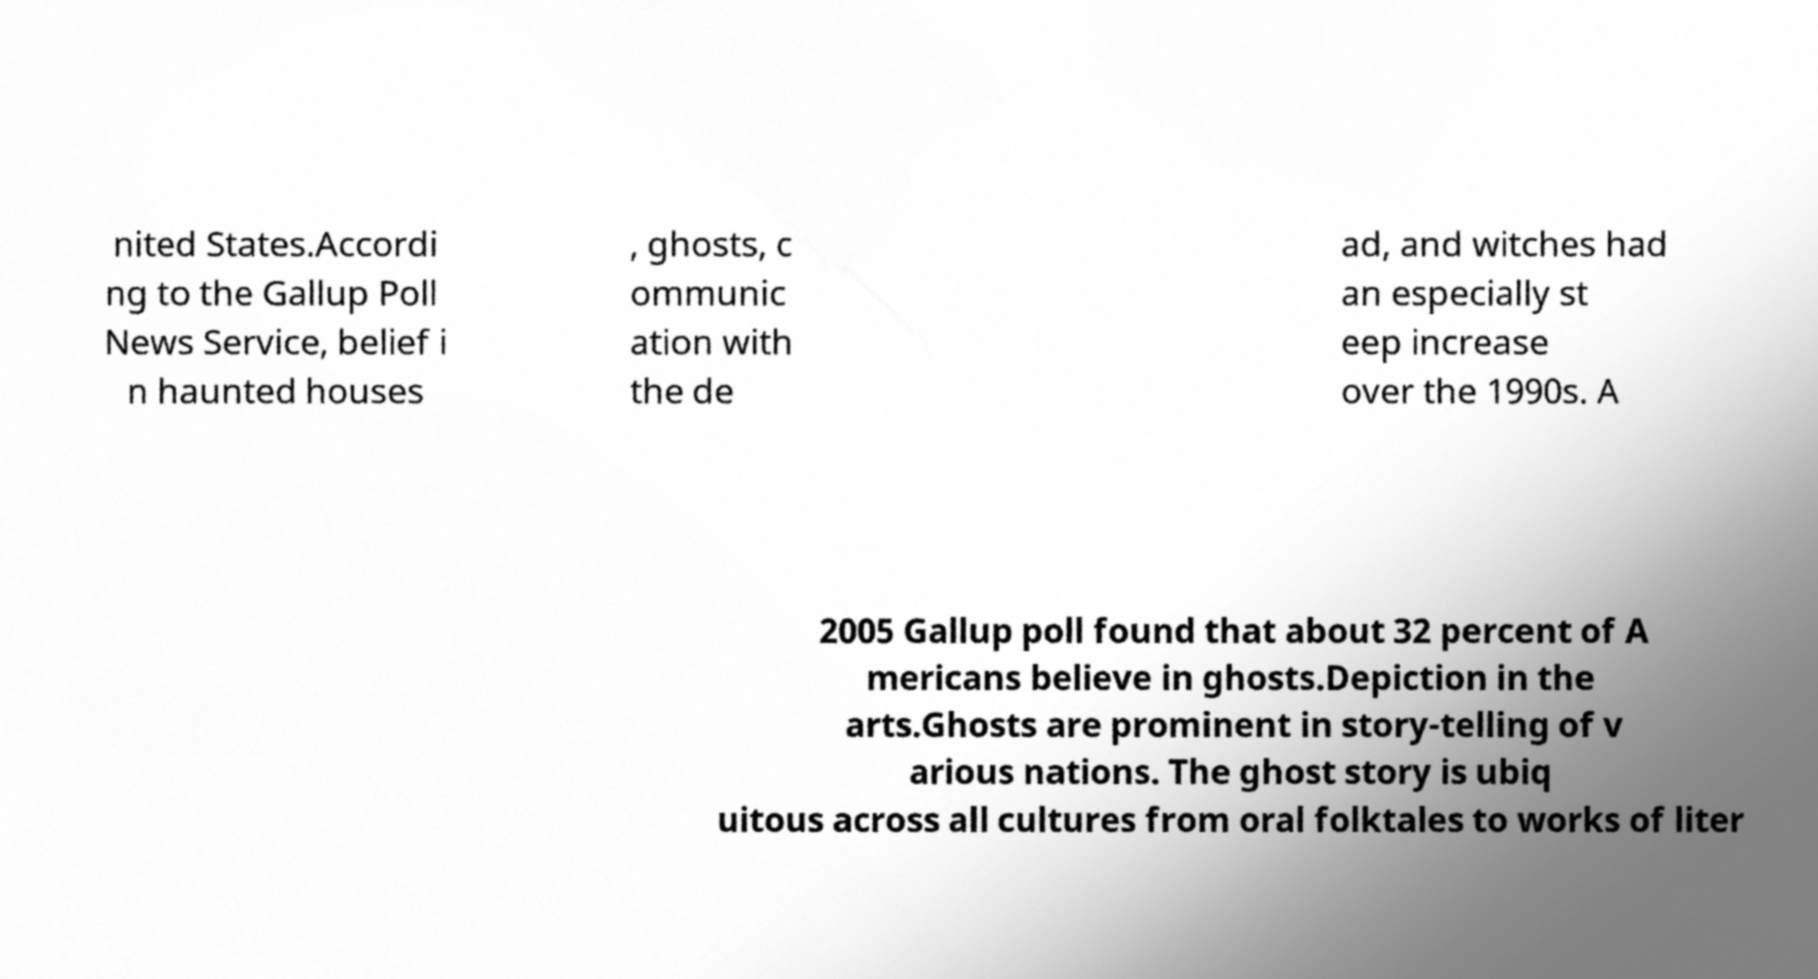What messages or text are displayed in this image? I need them in a readable, typed format. nited States.Accordi ng to the Gallup Poll News Service, belief i n haunted houses , ghosts, c ommunic ation with the de ad, and witches had an especially st eep increase over the 1990s. A 2005 Gallup poll found that about 32 percent of A mericans believe in ghosts.Depiction in the arts.Ghosts are prominent in story-telling of v arious nations. The ghost story is ubiq uitous across all cultures from oral folktales to works of liter 